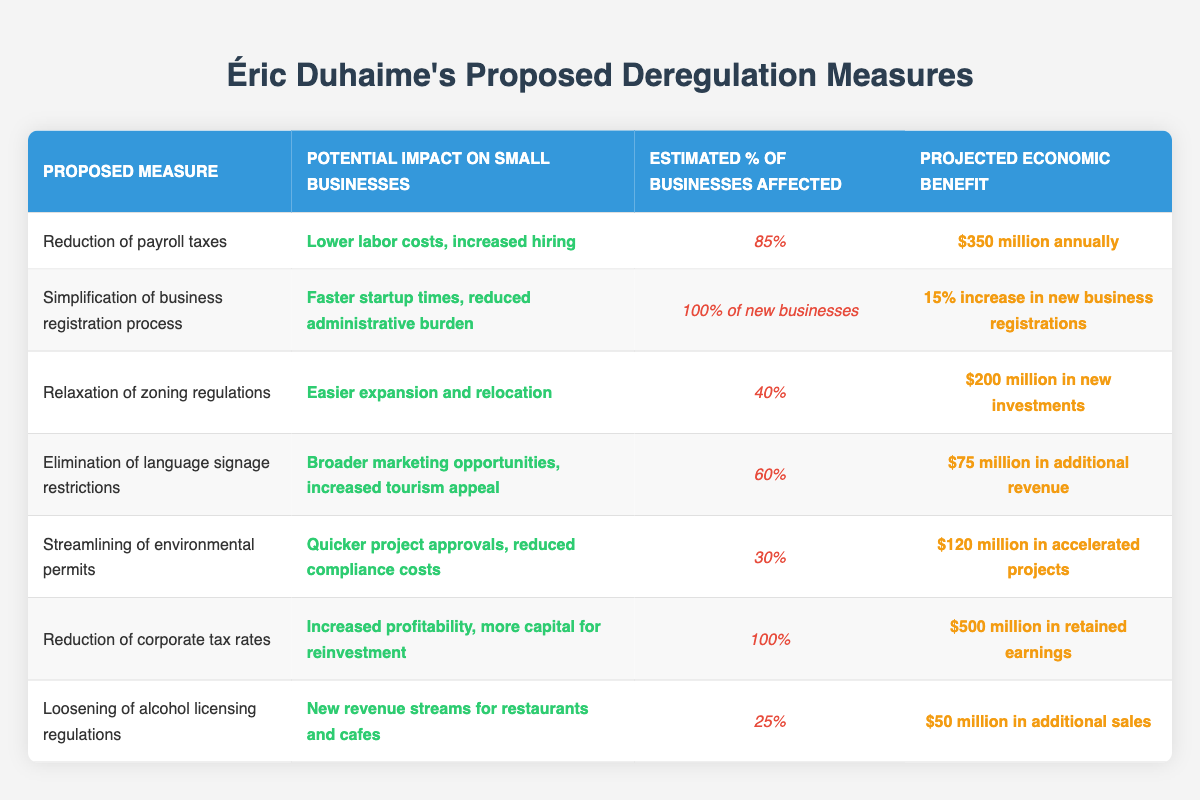What is the projected economic benefit of reducing corporate tax rates? According to the table, the projected economic benefit of reducing corporate tax rates is listed under the "Projected Economic Benefit" column, which shows $500 million in retained earnings.
Answer: $500 million in retained earnings Which proposed measure affects the highest percentage of businesses? Looking at the "Estimated % of Businesses Affected" column, "Simplification of business registration process" affects 100% of new businesses, which is the highest percentage when compared to other measures.
Answer: Simplification of business registration process What is the total projected economic benefit from both the reduction of payroll taxes and the relaxation of zoning regulations? The projected economic benefit from reducing payroll taxes is $350 million and from relaxing zoning regulations is $200 million. To find the total, add these two amounts: $350 million + $200 million = $550 million.
Answer: $550 million Does the streamlining of environmental permits impact more than 30% of businesses? The "Estimated % of Businesses Affected" for streamlining environmental permits is 30%. Since the percentage is not greater than 30%, the answer is no.
Answer: No How many measures have a projected economic benefit under $100 million? Inspecting the "Projected Economic Benefit" column, we see that two measures, "Elimination of language signage restrictions" ($75 million) and "Loosening of alcohol licensing regulations" ($50 million), have projected economic benefits under $100 million. Therefore, the count is 2.
Answer: 2 